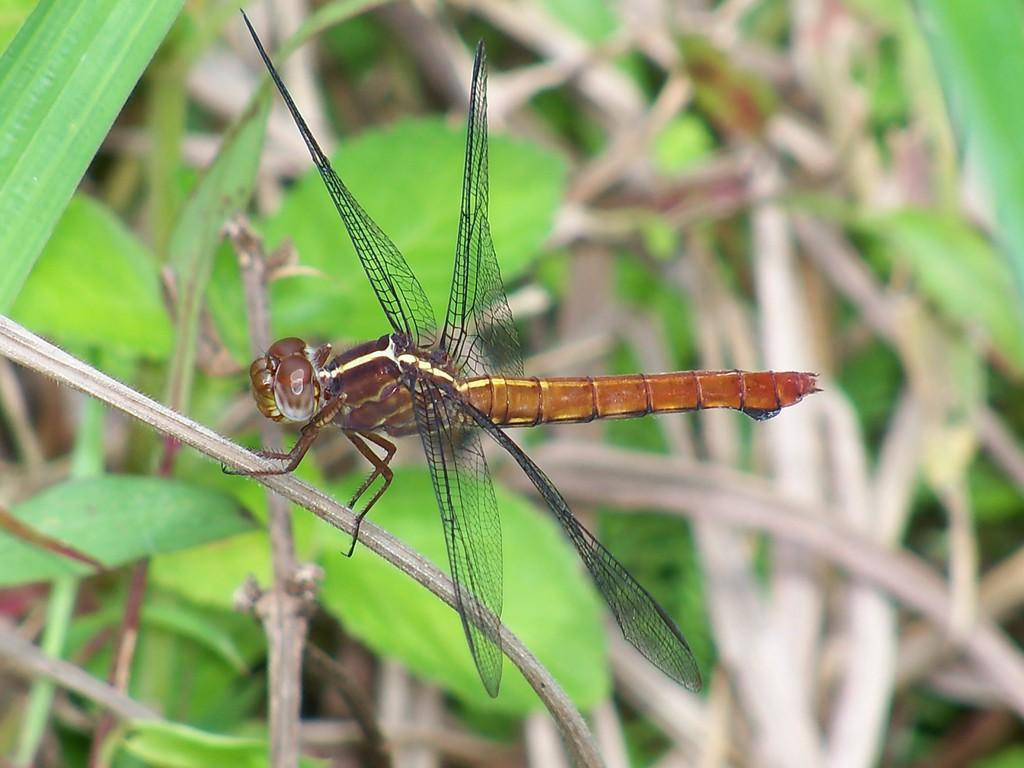What is on the tree branch in the image? There is a fly on a tree branch in the image. What can be seen in the background of the image? There are plants visible in the background of the image. What type of stamp is the fly using to stick to the tree branch in the image? There is no stamp present in the image, and the fly is not using any adhesive to stick to the tree branch. 